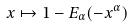Convert formula to latex. <formula><loc_0><loc_0><loc_500><loc_500>x \mapsto 1 - E _ { \alpha } ( - x ^ { \alpha } )</formula> 